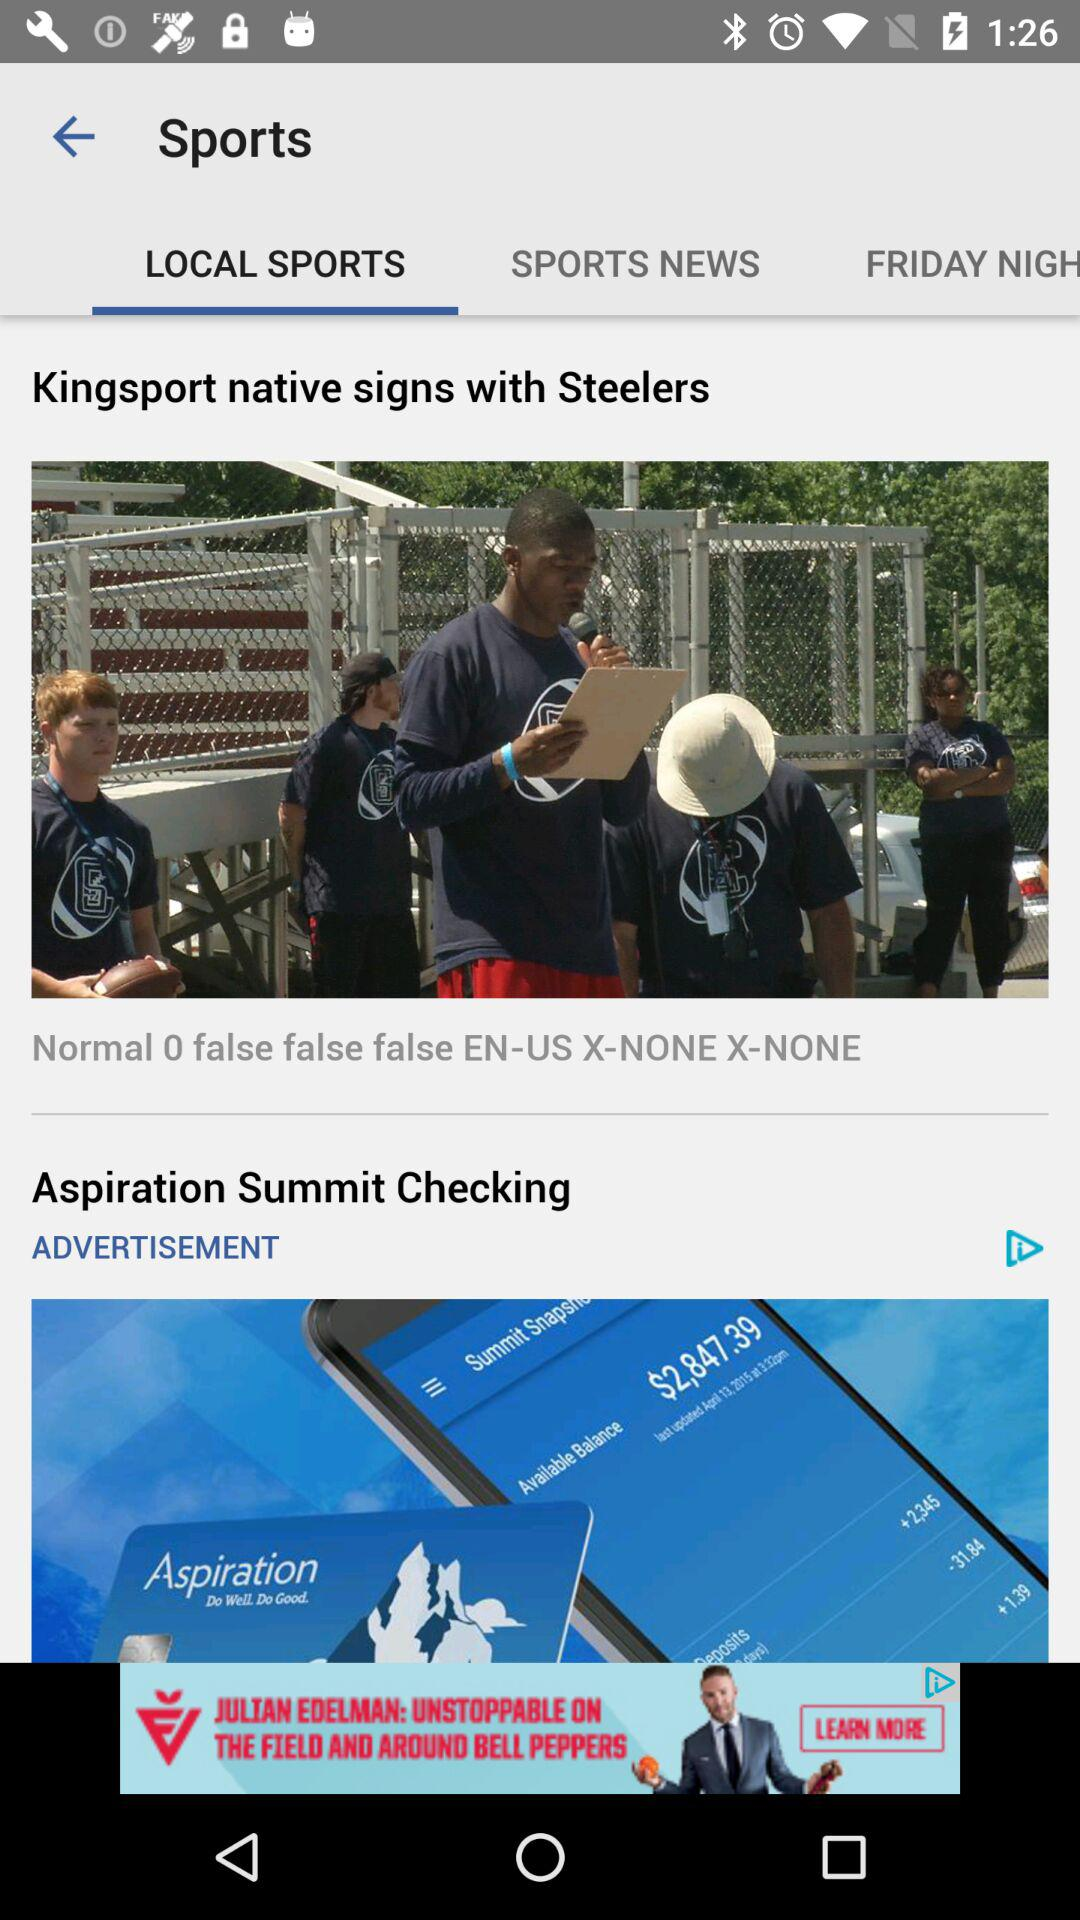In Sports, which tab is selected? The selected tab is "LOCAL SPORTS". 